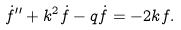<formula> <loc_0><loc_0><loc_500><loc_500>\dot { f } ^ { \prime \prime } + k ^ { 2 } \dot { f } - q \dot { f } = - 2 k f .</formula> 